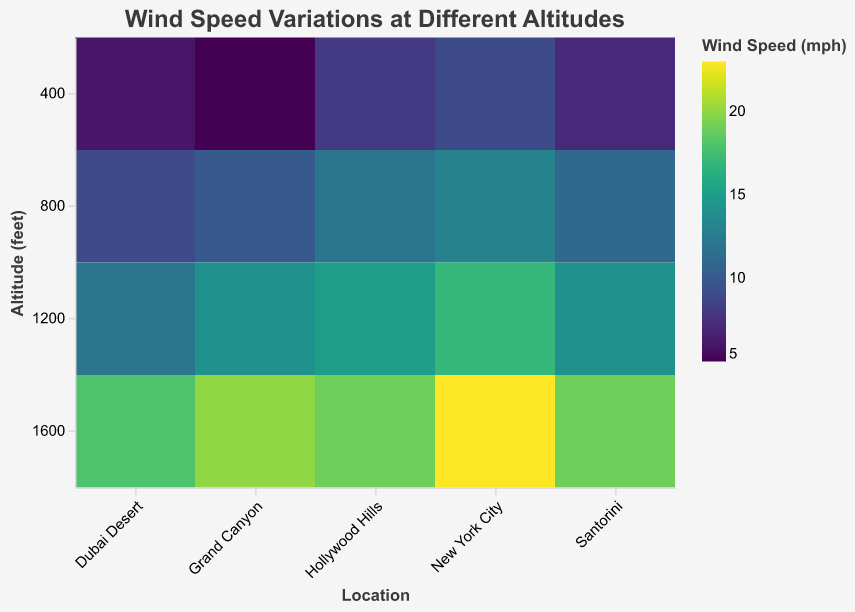What's the title of the heatmap? The title is a text element usually displayed at the top of the heatmap. It provides a brief description of what the visual represents.
Answer: Wind Speed Variations at Different Altitudes Which location has the highest wind speed at 1600 feet? To find this, look at the color intensity for the 1600 feet altitude level across different locations. The most intense color will represent the highest wind speed.
Answer: New York City At which altitude does Hollywood Hills experience a wind speed of 15 mph? Locate the row for Hollywood Hills and check the cell with a value of 15 mph to find the corresponding altitude.
Answer: 1200 feet How does the wind speed at 400 feet in Grand Canyon compare to the wind speed at 1600 feet in Dubai Desert? Compare the color intensity for Grand Canyon at 400 feet and Dubai Desert at 1600 feet. The less intense color represents a lower wind speed.
Answer: 400 feet in Grand Canyon is lower What's the average wind speed at 1200 feet across all locations? Sum the wind speeds at 1200 feet for all locations and divide by the number of locations (5). The wind speeds are 15, 14, 17, 12, and 14 mph, so (15+14+17+12+14)/5 = 72/5 = 14.4 mph
Answer: 14.4 mph Which location has the most consistent wind speed across all altitudes? Look for the location column where the color variations are the least intense, indicating smaller changes in wind speeds.
Answer: Dubai Desert At 800 feet, which location has the lowest wind speed? Examine the 800 feet row to find the cell with the least intense color to determine the lowest wind speed.
Answer: Grand Canyon How much does the wind speed in Santorini increase from 400 feet to 1600 feet? Find the wind speed at 400 feet and at 1600 feet in Santorini, then subtract the former from the latter (19 - 7 = 12 mph).
Answer: 12 mph What's the median wind speed at 400 feet across all locations? List the wind speeds at 400 feet (8, 5, 9, 6, 7 mph), and find the middle value. When ordered (5, 6, 7, 8, 9), the median is the third value.
Answer: 7 mph At which altitude does New York City have a wind speed of 13 mph? Find the row labeled New York City and identify the altitude where the color represents a wind speed of 13 mph.
Answer: 800 feet 